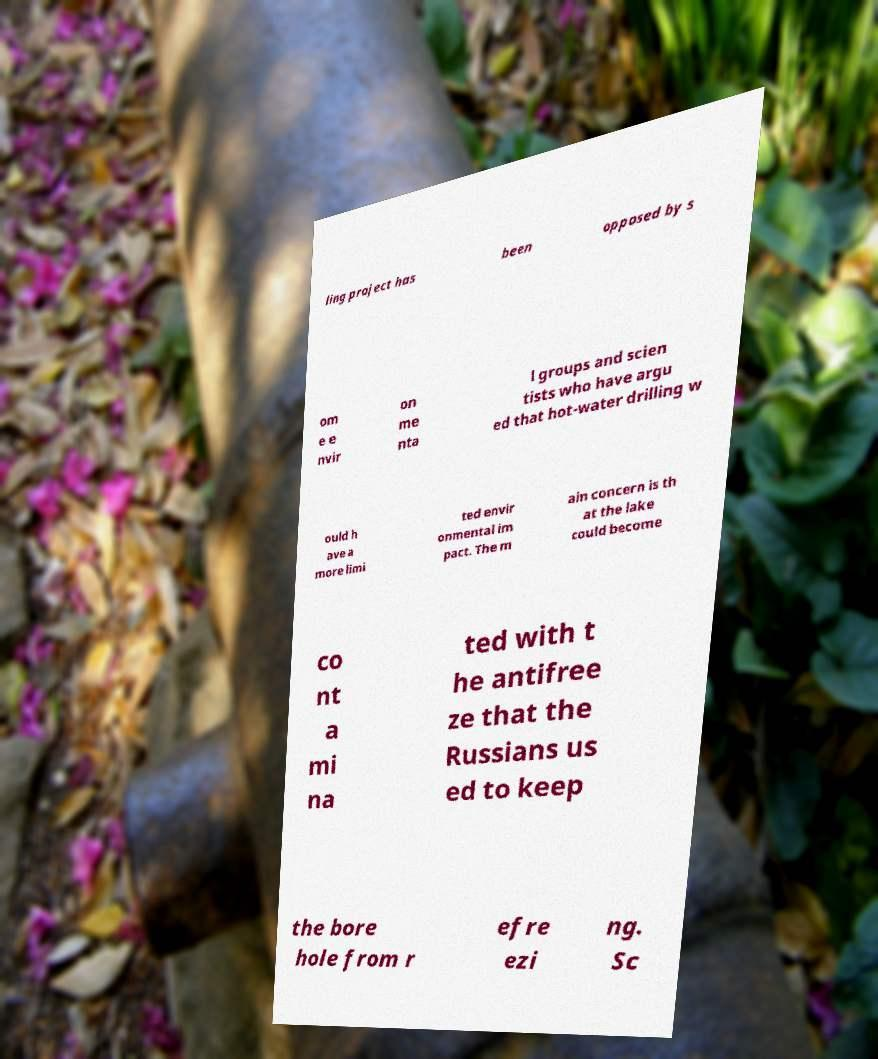Please read and relay the text visible in this image. What does it say? ling project has been opposed by s om e e nvir on me nta l groups and scien tists who have argu ed that hot-water drilling w ould h ave a more limi ted envir onmental im pact. The m ain concern is th at the lake could become co nt a mi na ted with t he antifree ze that the Russians us ed to keep the bore hole from r efre ezi ng. Sc 